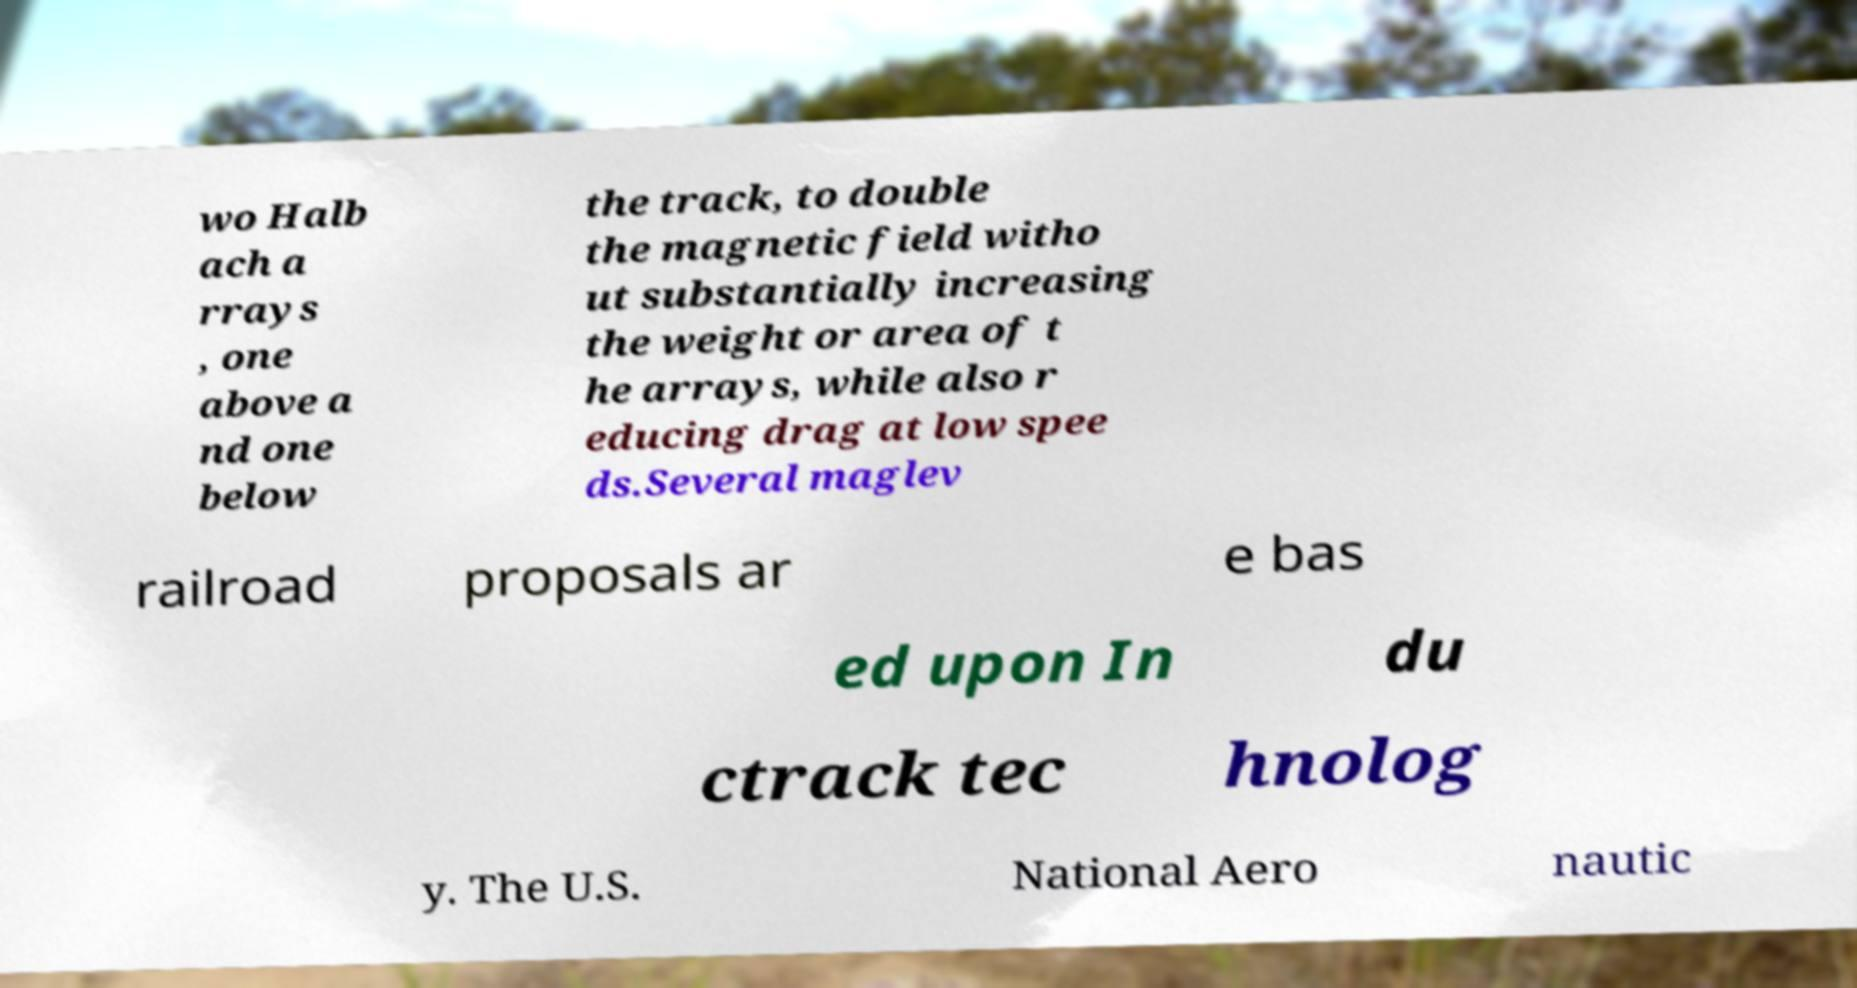There's text embedded in this image that I need extracted. Can you transcribe it verbatim? wo Halb ach a rrays , one above a nd one below the track, to double the magnetic field witho ut substantially increasing the weight or area of t he arrays, while also r educing drag at low spee ds.Several maglev railroad proposals ar e bas ed upon In du ctrack tec hnolog y. The U.S. National Aero nautic 